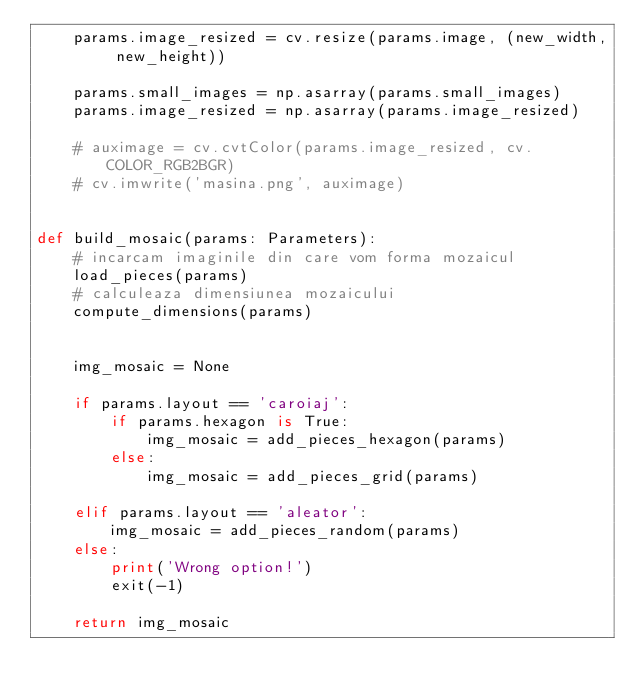<code> <loc_0><loc_0><loc_500><loc_500><_Python_>    params.image_resized = cv.resize(params.image, (new_width, new_height))
    
    params.small_images = np.asarray(params.small_images)
    params.image_resized = np.asarray(params.image_resized)
    
    # auximage = cv.cvtColor(params.image_resized, cv.COLOR_RGB2BGR)
    # cv.imwrite('masina.png', auximage)


def build_mosaic(params: Parameters):
    # incarcam imaginile din care vom forma mozaicul
    load_pieces(params)
    # calculeaza dimensiunea mozaicului
    compute_dimensions(params)


    img_mosaic = None
    
    if params.layout == 'caroiaj':
        if params.hexagon is True:
            img_mosaic = add_pieces_hexagon(params)
        else:
            img_mosaic = add_pieces_grid(params)
            
    elif params.layout == 'aleator':
        img_mosaic = add_pieces_random(params)
    else:
        print('Wrong option!')
        exit(-1)

    return img_mosaic

</code> 